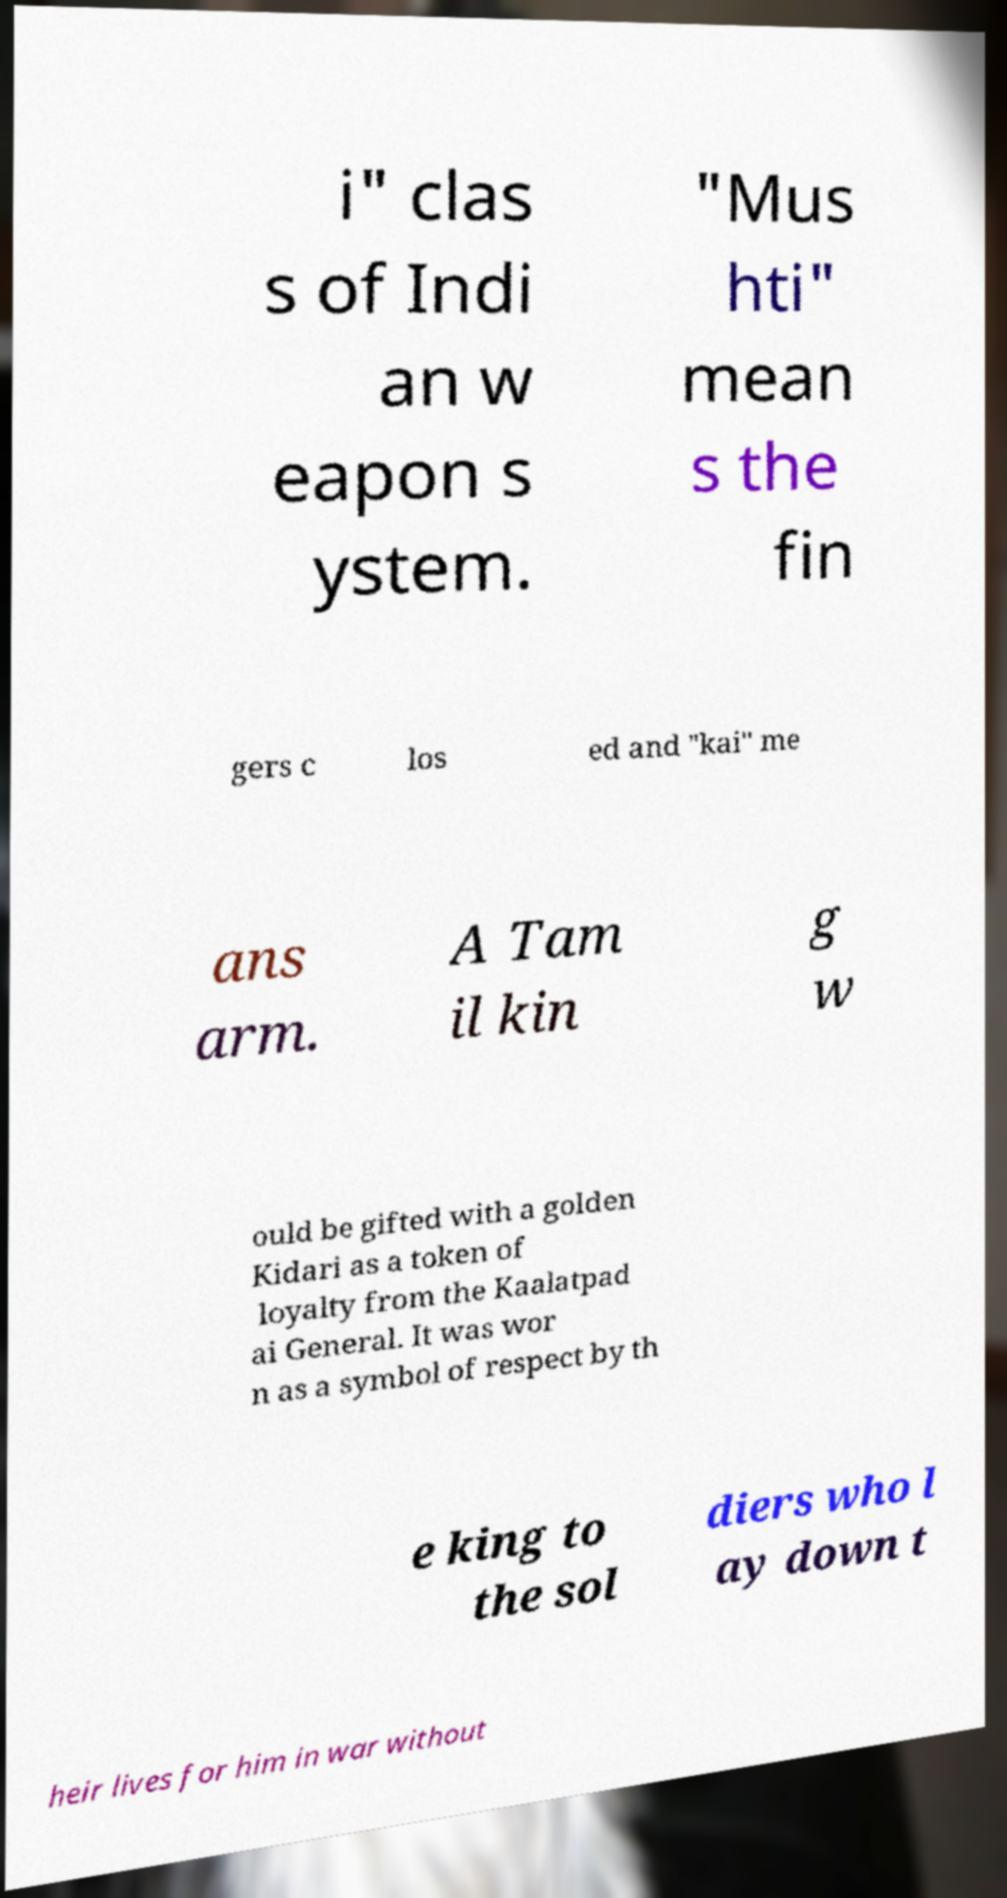Can you read and provide the text displayed in the image?This photo seems to have some interesting text. Can you extract and type it out for me? i" clas s of Indi an w eapon s ystem. "Mus hti" mean s the fin gers c los ed and "kai" me ans arm. A Tam il kin g w ould be gifted with a golden Kidari as a token of loyalty from the Kaalatpad ai General. It was wor n as a symbol of respect by th e king to the sol diers who l ay down t heir lives for him in war without 